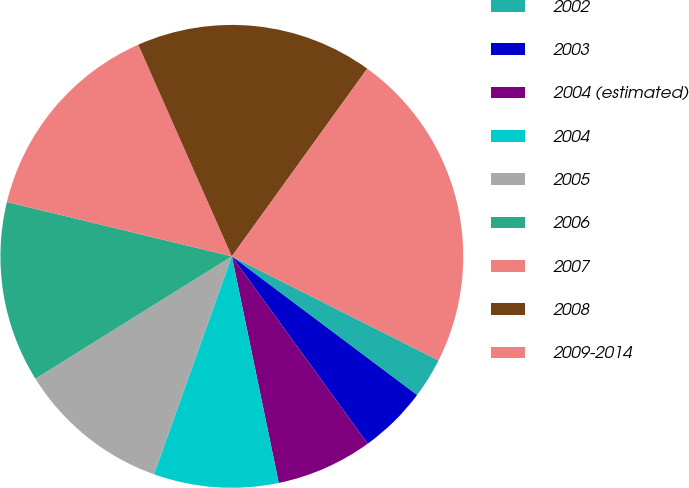Convert chart to OTSL. <chart><loc_0><loc_0><loc_500><loc_500><pie_chart><fcel>2002<fcel>2003<fcel>2004 (estimated)<fcel>2004<fcel>2005<fcel>2006<fcel>2007<fcel>2008<fcel>2009-2014<nl><fcel>2.81%<fcel>4.78%<fcel>6.74%<fcel>8.71%<fcel>10.67%<fcel>12.64%<fcel>14.6%<fcel>16.57%<fcel>22.47%<nl></chart> 